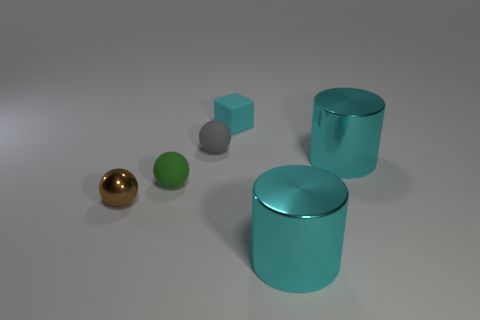Add 4 small gray matte spheres. How many objects exist? 10 Subtract all cylinders. How many objects are left? 4 Add 1 yellow things. How many yellow things exist? 1 Subtract 0 gray cubes. How many objects are left? 6 Subtract all blue rubber cylinders. Subtract all tiny gray balls. How many objects are left? 5 Add 5 cyan matte cubes. How many cyan matte cubes are left? 6 